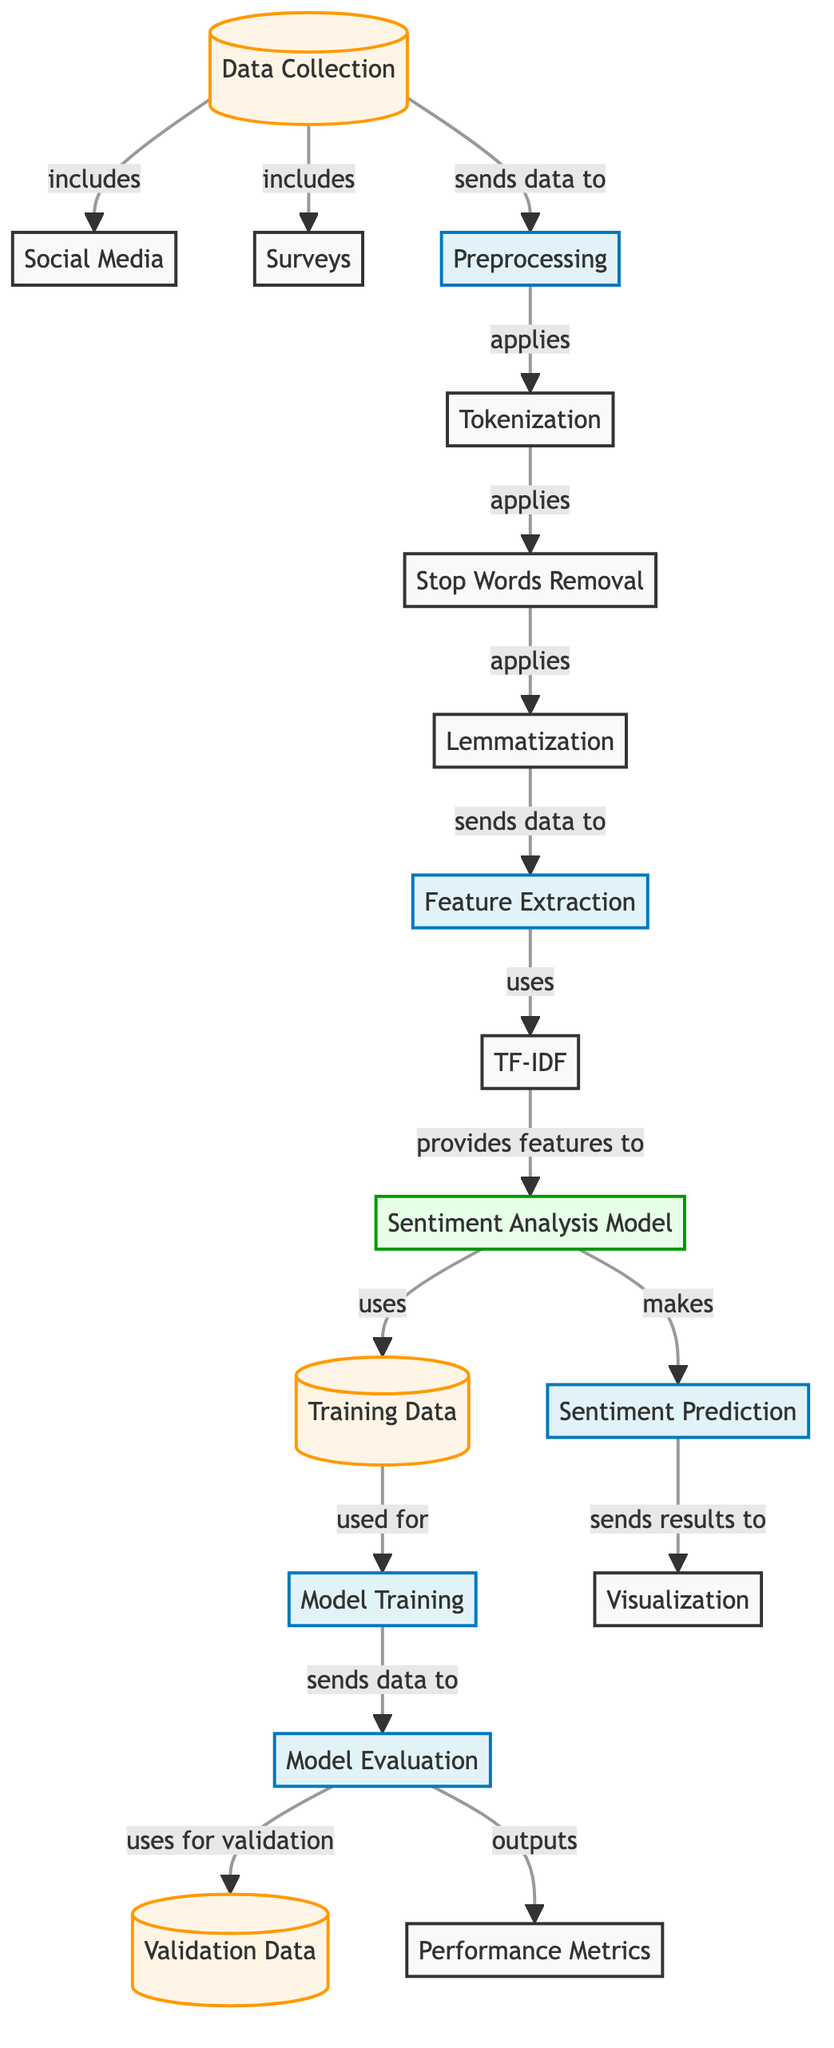What are the two sources of data collection? The diagram indicates that the data collection includes "Social Media" and "Surveys" as its two sources.
Answer: Social Media, Surveys Which step comes after stop words removal? Following the "Stop Words Removal" process, the next step is "Lemmatization," which is shown as the subsequent node in the flow.
Answer: Lemmatization How many processes are involved in preprocessing? There are three processes specified in the preprocessing phase: "Tokenization," "Stop Words Removal," and "Lemmatization." Counting these processes gives a total of three.
Answer: 3 What is the relationship between the sentiment analysis model and training data? The relationship shows that the "Sentiment Analysis Model" utilizes the "Training Data" for training, indicated by the arrow pointing from the training data to the sentiment analysis model.
Answer: uses What is the output after model evaluation? After the "Model Evaluation" step, it outputs "Performance Metrics," which is directly connected from the evaluation process as shown in the diagram.
Answer: Performance Metrics What type of analysis is performed in the model? The model in this diagram performs "Sentiment Analysis," as stated directly on the node representing the analysis model.
Answer: Sentiment Analysis What is the purpose of TF-IDF in the diagram? TF-IDF is used for "Feature Extraction," as indicated in the diagram, where it provides features for the sentiment analysis model.
Answer: Feature Extraction How many nodes represent data? In the diagram, there are four nodes specifically representing data: "Data Collection," "Training Data," "Validation Data," and "Sentiment Prediction," making a total of four nodes.
Answer: 4 